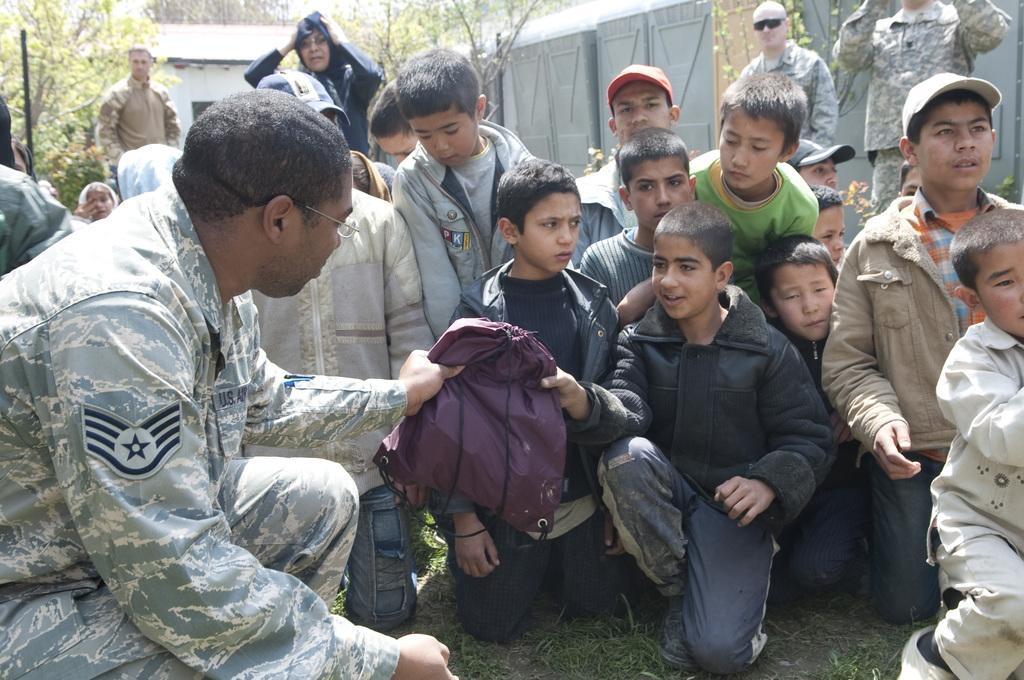Please provide a concise description of this image. In this image there are many kids. Here is a man holding a bag. In the background there are other people's, buildings, wall, and trees are there. 